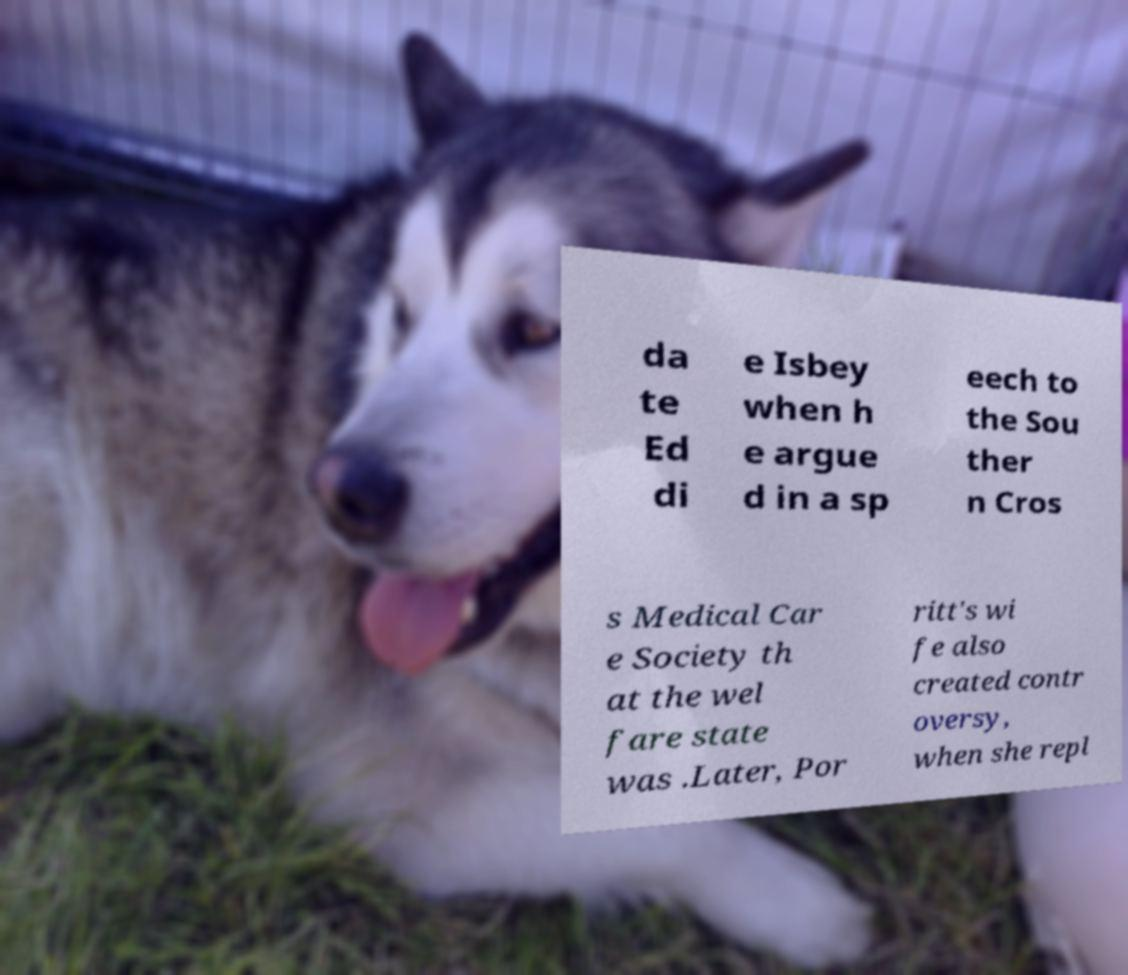Could you extract and type out the text from this image? da te Ed di e Isbey when h e argue d in a sp eech to the Sou ther n Cros s Medical Car e Society th at the wel fare state was .Later, Por ritt's wi fe also created contr oversy, when she repl 